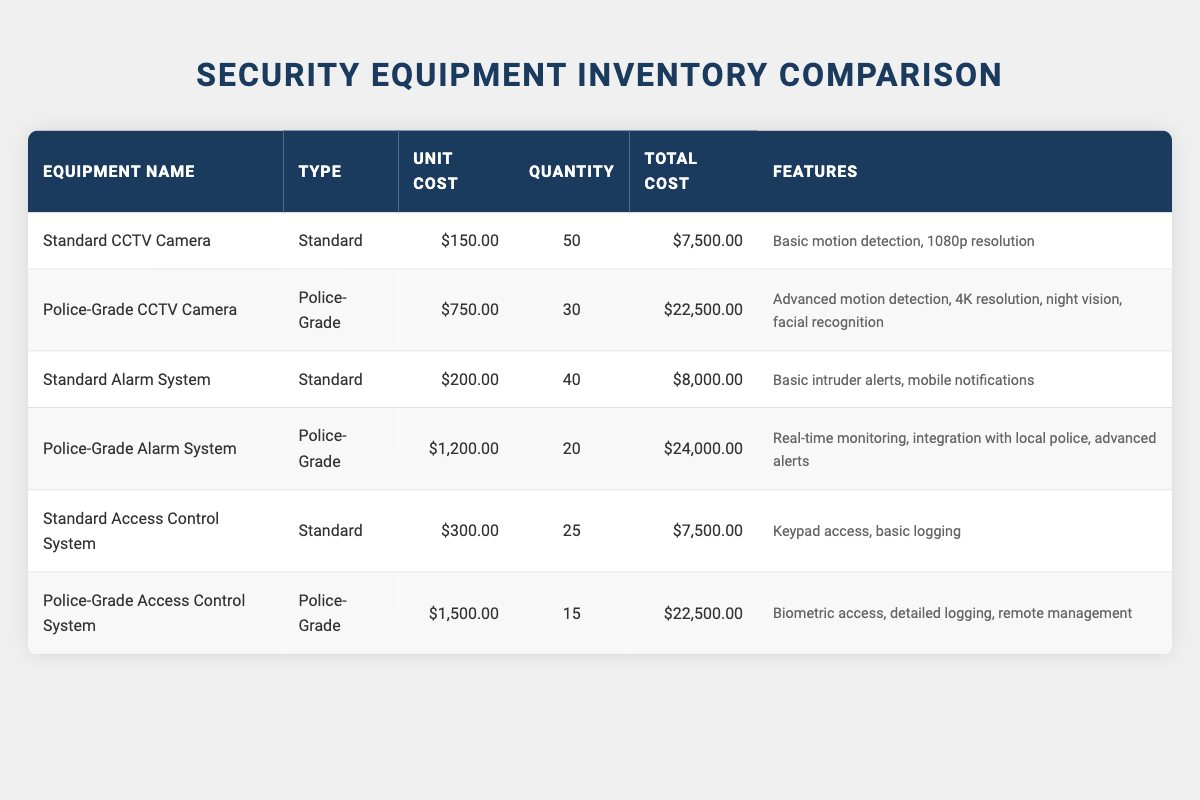What is the total cost of Standard CCTV Cameras? The unit cost of a Standard CCTV Camera is $150.00, and there are 50 units. The total cost is calculated by multiplying the unit cost by the quantity: 150 * 50 = 7500.00
Answer: 7500.00 What are the features of the Police-Grade Alarm System? According to the table, the features of the Police-Grade Alarm System include real-time monitoring, integration with local police, and advanced alerts.
Answer: Real-time monitoring, integration with local police, advanced alerts How much more expensive is the Police-Grade Access Control System compared to the Standard Access Control System? The unit cost of the Police-Grade Access Control System is $1,500.00, while the unit cost of the Standard Access Control System is $300.00. The difference is calculated by subtracting the Standard unit cost from the Police-Grade unit cost: 1500 - 300 = 1200.00.
Answer: 1200.00 What is the combined total cost of all Standard equipment? The total cost for Standard equipment includes: Standard CCTV Camera ($7,500.00), Standard Alarm System ($8,000.00), and Standard Access Control System ($7,500.00). Adding those together gives us: 7500 + 8000 + 7500 = 22,000.00.
Answer: 22000.00 Are there more Police-Grade or Standard devices in the inventory? There are 30 Police-Grade CCTV Cameras, 20 Police-Grade Alarm Systems, and 15 Police-Grade Access Control Systems, totaling 65 Police-Grade devices. For the Standard devices, there are 50 Standard CCTV Cameras, 40 Standard Alarm Systems, and 25 Standard Access Control Systems, totaling 115 Standard devices. Therefore, there are more Standard devices than Police-Grade devices.
Answer: No What is the average unit cost of all equipment types listed? To find the average unit cost, first note the unit costs: Standard CCTV Camera ($150), Police-Grade CCTV Camera ($750), Standard Alarm System ($200), Police-Grade Alarm System ($1,200), Standard Access Control System ($300), and Police-Grade Access Control System ($1,500). Adding these gives: 150 + 750 + 200 + 1200 + 300 + 1500 = 3100.00. There are 6 equipment types so the average unit cost is calculated as: 3100 / 6 = 516.67.
Answer: 516.67 What is the total quantity of Police-Grade equipment available? For Police-Grade equipment, the quantity includes: 30 Police-Grade CCTV Cameras, 20 Police-Grade Alarm Systems, and 15 Police-Grade Access Control Systems. Adding these yields: 30 + 20 + 15 = 65.
Answer: 65 Which equipment type has the highest total cost? The total costs are: Police-Grade Alarm System ($24,000.00), Police-Grade CCTV Camera ($22,500.00), and Police-Grade Access Control System ($22,500.00). The highest total cost is for the Police-Grade Alarm System at $24,000.00.
Answer: Police-Grade Alarm System 